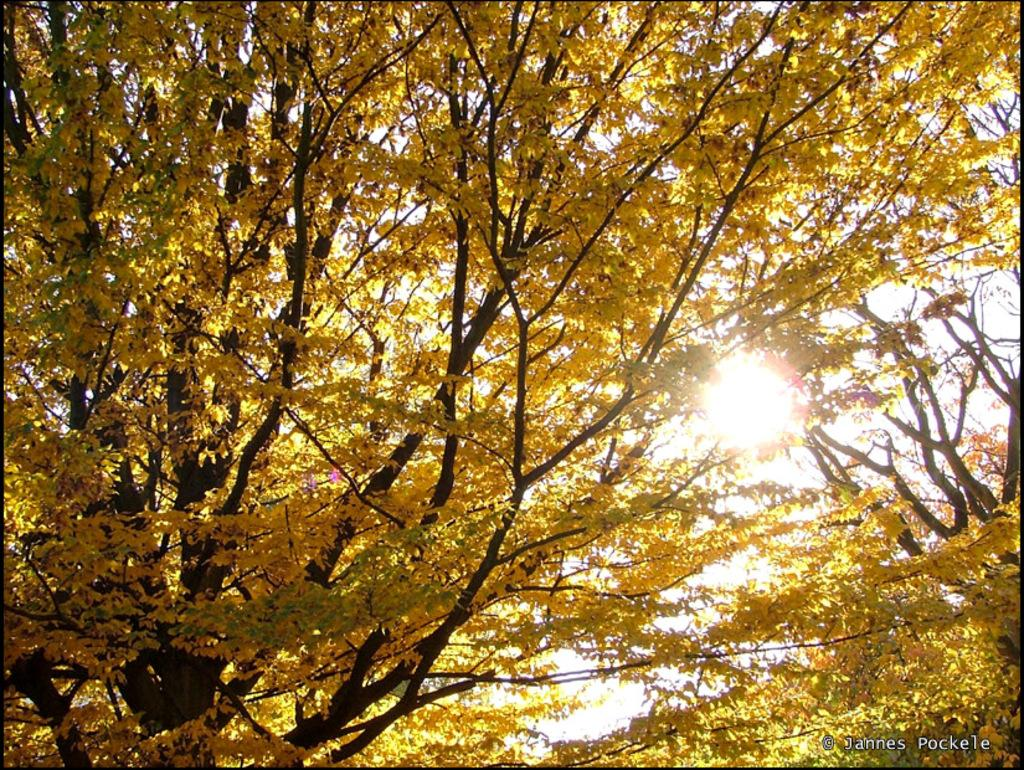What type of vegetation can be seen in the image? There are trees in the image. How many zippers can be seen on the trees in the image? There are no zippers present on the trees in the image, as zippers are not a natural part of trees. 